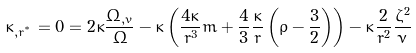Convert formula to latex. <formula><loc_0><loc_0><loc_500><loc_500>\kappa _ { , r ^ { ^ { * } } } = 0 = 2 \kappa \frac { \Omega _ { , v } } { \Omega } - \kappa \left ( \frac { 4 \kappa } { r ^ { 3 } } m + \frac { 4 } { 3 } \frac { \kappa } { r } \left ( \rho - \frac { 3 } { 2 } \right ) \right ) - \kappa \frac { 2 } { r ^ { 2 } } \frac { \zeta ^ { 2 } } { \nu }</formula> 